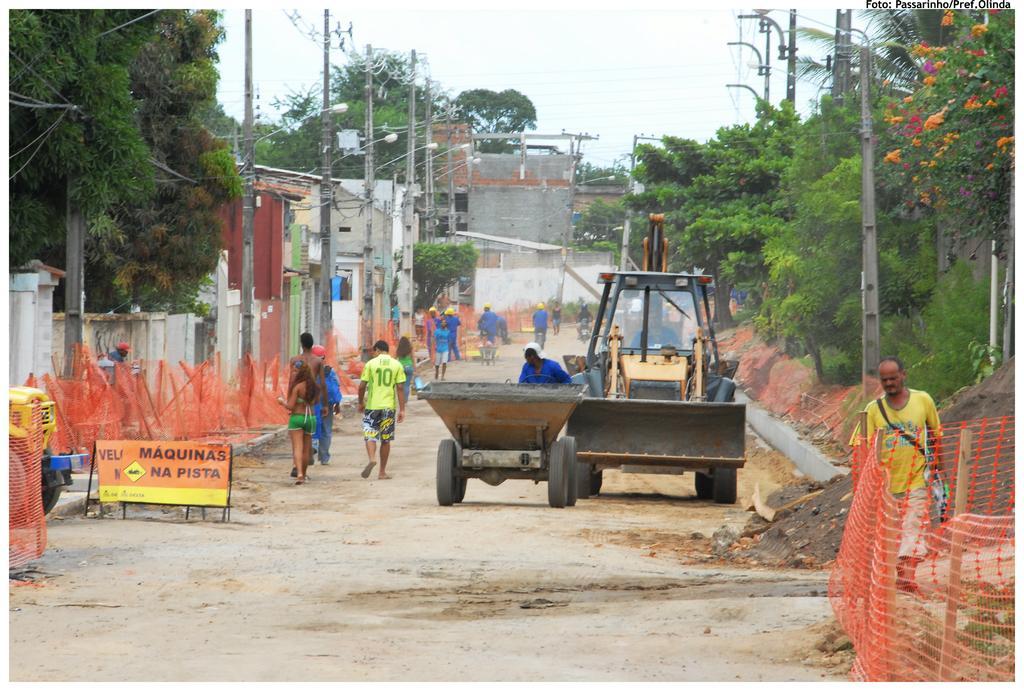Please provide a concise description of this image. In this image we can see two vehicles and a group of people walking on the road. We can also see a fence, a group of trees, street poles and a board. On the backside we can see a group of buildings and the sky which looks cloudy. 